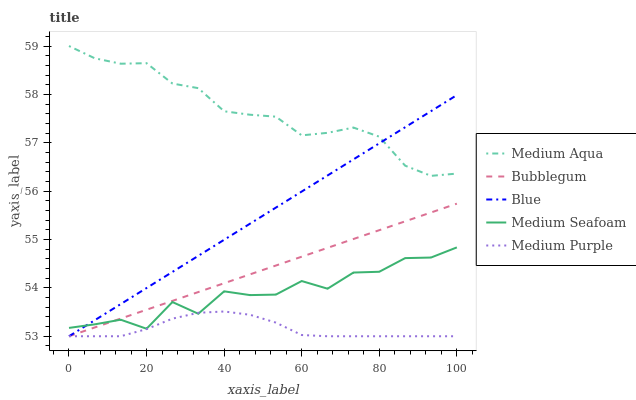Does Medium Purple have the minimum area under the curve?
Answer yes or no. Yes. Does Medium Aqua have the maximum area under the curve?
Answer yes or no. Yes. Does Medium Aqua have the minimum area under the curve?
Answer yes or no. No. Does Medium Purple have the maximum area under the curve?
Answer yes or no. No. Is Blue the smoothest?
Answer yes or no. Yes. Is Medium Seafoam the roughest?
Answer yes or no. Yes. Is Medium Purple the smoothest?
Answer yes or no. No. Is Medium Purple the roughest?
Answer yes or no. No. Does Blue have the lowest value?
Answer yes or no. Yes. Does Medium Aqua have the lowest value?
Answer yes or no. No. Does Medium Aqua have the highest value?
Answer yes or no. Yes. Does Medium Purple have the highest value?
Answer yes or no. No. Is Medium Seafoam less than Medium Aqua?
Answer yes or no. Yes. Is Medium Aqua greater than Bubblegum?
Answer yes or no. Yes. Does Bubblegum intersect Medium Purple?
Answer yes or no. Yes. Is Bubblegum less than Medium Purple?
Answer yes or no. No. Is Bubblegum greater than Medium Purple?
Answer yes or no. No. Does Medium Seafoam intersect Medium Aqua?
Answer yes or no. No. 